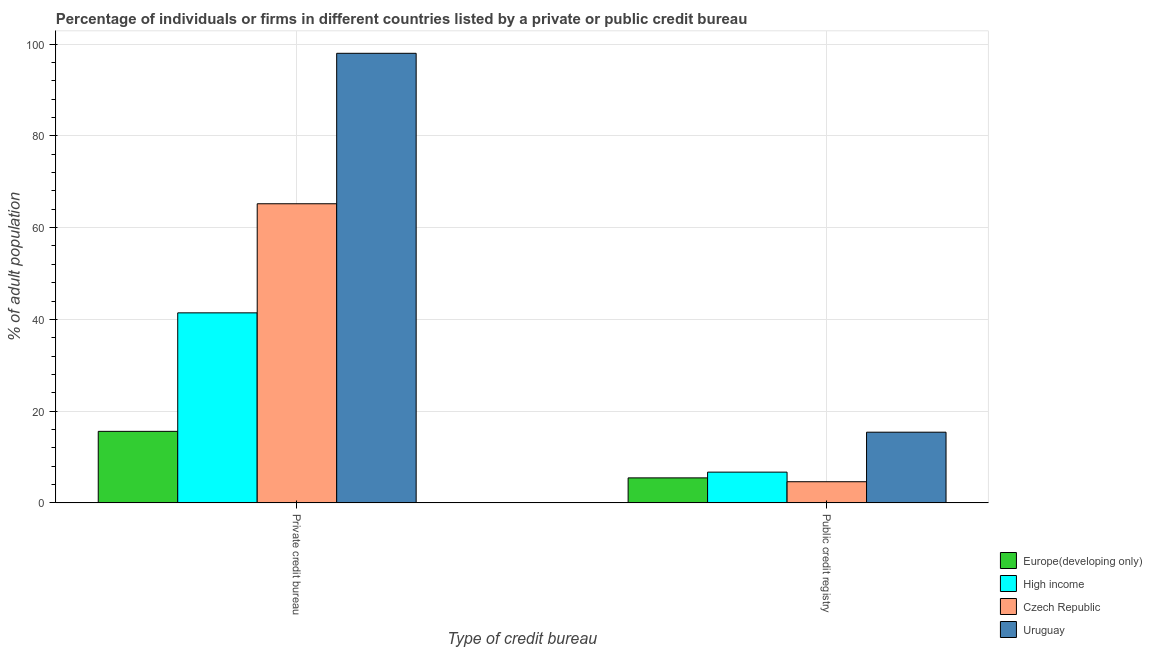How many different coloured bars are there?
Offer a terse response. 4. How many groups of bars are there?
Make the answer very short. 2. How many bars are there on the 2nd tick from the left?
Provide a succinct answer. 4. What is the label of the 2nd group of bars from the left?
Make the answer very short. Public credit registry. Across all countries, what is the maximum percentage of firms listed by public credit bureau?
Your answer should be very brief. 15.4. Across all countries, what is the minimum percentage of firms listed by private credit bureau?
Provide a short and direct response. 15.58. In which country was the percentage of firms listed by private credit bureau maximum?
Provide a short and direct response. Uruguay. In which country was the percentage of firms listed by private credit bureau minimum?
Give a very brief answer. Europe(developing only). What is the total percentage of firms listed by private credit bureau in the graph?
Offer a very short reply. 220.2. What is the difference between the percentage of firms listed by public credit bureau in High income and that in Uruguay?
Offer a terse response. -8.71. What is the difference between the percentage of firms listed by private credit bureau in High income and the percentage of firms listed by public credit bureau in Europe(developing only)?
Offer a very short reply. 35.98. What is the average percentage of firms listed by public credit bureau per country?
Give a very brief answer. 8.03. What is the difference between the percentage of firms listed by private credit bureau and percentage of firms listed by public credit bureau in Uruguay?
Your answer should be very brief. 82.6. What is the ratio of the percentage of firms listed by public credit bureau in Europe(developing only) to that in Uruguay?
Your answer should be very brief. 0.35. In how many countries, is the percentage of firms listed by private credit bureau greater than the average percentage of firms listed by private credit bureau taken over all countries?
Give a very brief answer. 2. What does the 1st bar from the left in Public credit registry represents?
Keep it short and to the point. Europe(developing only). What does the 1st bar from the right in Public credit registry represents?
Provide a succinct answer. Uruguay. How many bars are there?
Ensure brevity in your answer.  8. Are the values on the major ticks of Y-axis written in scientific E-notation?
Offer a terse response. No. Does the graph contain any zero values?
Keep it short and to the point. No. Does the graph contain grids?
Provide a succinct answer. Yes. What is the title of the graph?
Ensure brevity in your answer.  Percentage of individuals or firms in different countries listed by a private or public credit bureau. What is the label or title of the X-axis?
Offer a terse response. Type of credit bureau. What is the label or title of the Y-axis?
Make the answer very short. % of adult population. What is the % of adult population in Europe(developing only) in Private credit bureau?
Provide a short and direct response. 15.58. What is the % of adult population of High income in Private credit bureau?
Make the answer very short. 41.42. What is the % of adult population in Czech Republic in Private credit bureau?
Make the answer very short. 65.2. What is the % of adult population in Europe(developing only) in Public credit registry?
Your answer should be very brief. 5.44. What is the % of adult population of High income in Public credit registry?
Your answer should be compact. 6.69. What is the % of adult population in Uruguay in Public credit registry?
Your answer should be very brief. 15.4. Across all Type of credit bureau, what is the maximum % of adult population of Europe(developing only)?
Provide a succinct answer. 15.58. Across all Type of credit bureau, what is the maximum % of adult population of High income?
Provide a short and direct response. 41.42. Across all Type of credit bureau, what is the maximum % of adult population in Czech Republic?
Provide a succinct answer. 65.2. Across all Type of credit bureau, what is the maximum % of adult population in Uruguay?
Keep it short and to the point. 98. Across all Type of credit bureau, what is the minimum % of adult population in Europe(developing only)?
Your answer should be very brief. 5.44. Across all Type of credit bureau, what is the minimum % of adult population in High income?
Provide a short and direct response. 6.69. Across all Type of credit bureau, what is the minimum % of adult population in Czech Republic?
Keep it short and to the point. 4.6. Across all Type of credit bureau, what is the minimum % of adult population in Uruguay?
Offer a very short reply. 15.4. What is the total % of adult population of Europe(developing only) in the graph?
Your answer should be very brief. 21.02. What is the total % of adult population in High income in the graph?
Give a very brief answer. 48.11. What is the total % of adult population in Czech Republic in the graph?
Provide a succinct answer. 69.8. What is the total % of adult population in Uruguay in the graph?
Offer a terse response. 113.4. What is the difference between the % of adult population in Europe(developing only) in Private credit bureau and that in Public credit registry?
Your response must be concise. 10.14. What is the difference between the % of adult population of High income in Private credit bureau and that in Public credit registry?
Provide a succinct answer. 34.73. What is the difference between the % of adult population of Czech Republic in Private credit bureau and that in Public credit registry?
Your answer should be very brief. 60.6. What is the difference between the % of adult population of Uruguay in Private credit bureau and that in Public credit registry?
Your answer should be very brief. 82.6. What is the difference between the % of adult population in Europe(developing only) in Private credit bureau and the % of adult population in High income in Public credit registry?
Provide a succinct answer. 8.89. What is the difference between the % of adult population of Europe(developing only) in Private credit bureau and the % of adult population of Czech Republic in Public credit registry?
Ensure brevity in your answer.  10.98. What is the difference between the % of adult population in Europe(developing only) in Private credit bureau and the % of adult population in Uruguay in Public credit registry?
Make the answer very short. 0.18. What is the difference between the % of adult population of High income in Private credit bureau and the % of adult population of Czech Republic in Public credit registry?
Your answer should be compact. 36.82. What is the difference between the % of adult population of High income in Private credit bureau and the % of adult population of Uruguay in Public credit registry?
Keep it short and to the point. 26.02. What is the difference between the % of adult population of Czech Republic in Private credit bureau and the % of adult population of Uruguay in Public credit registry?
Offer a terse response. 49.8. What is the average % of adult population in Europe(developing only) per Type of credit bureau?
Provide a succinct answer. 10.51. What is the average % of adult population in High income per Type of credit bureau?
Your answer should be very brief. 24.05. What is the average % of adult population of Czech Republic per Type of credit bureau?
Provide a short and direct response. 34.9. What is the average % of adult population in Uruguay per Type of credit bureau?
Offer a very short reply. 56.7. What is the difference between the % of adult population in Europe(developing only) and % of adult population in High income in Private credit bureau?
Your answer should be compact. -25.83. What is the difference between the % of adult population of Europe(developing only) and % of adult population of Czech Republic in Private credit bureau?
Offer a terse response. -49.62. What is the difference between the % of adult population in Europe(developing only) and % of adult population in Uruguay in Private credit bureau?
Provide a succinct answer. -82.42. What is the difference between the % of adult population of High income and % of adult population of Czech Republic in Private credit bureau?
Offer a very short reply. -23.78. What is the difference between the % of adult population of High income and % of adult population of Uruguay in Private credit bureau?
Your answer should be very brief. -56.58. What is the difference between the % of adult population of Czech Republic and % of adult population of Uruguay in Private credit bureau?
Your answer should be compact. -32.8. What is the difference between the % of adult population of Europe(developing only) and % of adult population of High income in Public credit registry?
Provide a short and direct response. -1.25. What is the difference between the % of adult population in Europe(developing only) and % of adult population in Czech Republic in Public credit registry?
Offer a terse response. 0.84. What is the difference between the % of adult population in Europe(developing only) and % of adult population in Uruguay in Public credit registry?
Give a very brief answer. -9.96. What is the difference between the % of adult population of High income and % of adult population of Czech Republic in Public credit registry?
Give a very brief answer. 2.09. What is the difference between the % of adult population in High income and % of adult population in Uruguay in Public credit registry?
Provide a short and direct response. -8.71. What is the difference between the % of adult population of Czech Republic and % of adult population of Uruguay in Public credit registry?
Provide a succinct answer. -10.8. What is the ratio of the % of adult population of Europe(developing only) in Private credit bureau to that in Public credit registry?
Make the answer very short. 2.87. What is the ratio of the % of adult population in High income in Private credit bureau to that in Public credit registry?
Make the answer very short. 6.19. What is the ratio of the % of adult population of Czech Republic in Private credit bureau to that in Public credit registry?
Provide a short and direct response. 14.17. What is the ratio of the % of adult population in Uruguay in Private credit bureau to that in Public credit registry?
Your response must be concise. 6.36. What is the difference between the highest and the second highest % of adult population of Europe(developing only)?
Provide a short and direct response. 10.14. What is the difference between the highest and the second highest % of adult population in High income?
Your answer should be compact. 34.73. What is the difference between the highest and the second highest % of adult population of Czech Republic?
Provide a succinct answer. 60.6. What is the difference between the highest and the second highest % of adult population in Uruguay?
Provide a succinct answer. 82.6. What is the difference between the highest and the lowest % of adult population of Europe(developing only)?
Offer a very short reply. 10.14. What is the difference between the highest and the lowest % of adult population in High income?
Keep it short and to the point. 34.73. What is the difference between the highest and the lowest % of adult population of Czech Republic?
Your answer should be compact. 60.6. What is the difference between the highest and the lowest % of adult population in Uruguay?
Keep it short and to the point. 82.6. 